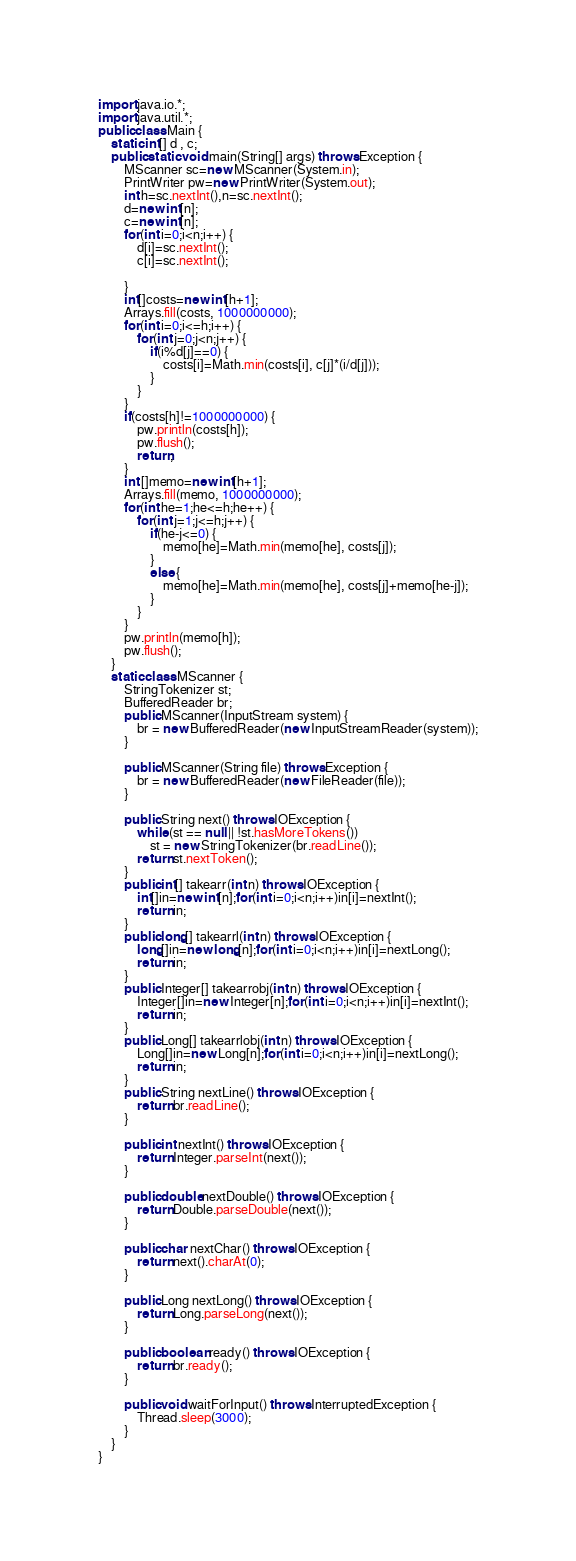Convert code to text. <code><loc_0><loc_0><loc_500><loc_500><_Java_>import java.io.*;
import java.util.*;
public class Main {
	static int[] d , c;
	public static void main(String[] args) throws Exception {
		MScanner sc=new MScanner(System.in);
		PrintWriter pw=new PrintWriter(System.out);
		int h=sc.nextInt(),n=sc.nextInt();
		d=new int[n];
		c=new int[n];
		for(int i=0;i<n;i++) {
			d[i]=sc.nextInt();
			c[i]=sc.nextInt();
			
		}
		int[]costs=new int[h+1];
		Arrays.fill(costs, 1000000000);
		for(int i=0;i<=h;i++) {
			for(int j=0;j<n;j++) {
				if(i%d[j]==0) {
					costs[i]=Math.min(costs[i], c[j]*(i/d[j]));
				}
			}
		}
		if(costs[h]!=1000000000) {
			pw.println(costs[h]);
			pw.flush();
			return;
		}
		int []memo=new int[h+1];
		Arrays.fill(memo, 1000000000);
		for(int he=1;he<=h;he++) {
			for(int j=1;j<=h;j++) {
				if(he-j<=0) {
					memo[he]=Math.min(memo[he], costs[j]);
				}
				else {
					memo[he]=Math.min(memo[he], costs[j]+memo[he-j]);
				}
			}
		}
		pw.println(memo[h]);
		pw.flush();
	}
	static class MScanner {
		StringTokenizer st;
		BufferedReader br;
		public MScanner(InputStream system) {
			br = new BufferedReader(new InputStreamReader(system));
		}
 
		public MScanner(String file) throws Exception {
			br = new BufferedReader(new FileReader(file));
		}
 
		public String next() throws IOException {
			while (st == null || !st.hasMoreTokens())
				st = new StringTokenizer(br.readLine());
			return st.nextToken();
		}
		public int[] takearr(int n) throws IOException {
	        int[]in=new int[n];for(int i=0;i<n;i++)in[i]=nextInt();
	        return in;
		}
		public long[] takearrl(int n) throws IOException {
	        long[]in=new long[n];for(int i=0;i<n;i++)in[i]=nextLong();
	        return in;
		}
		public Integer[] takearrobj(int n) throws IOException {
	        Integer[]in=new Integer[n];for(int i=0;i<n;i++)in[i]=nextInt();
	        return in;
		}
		public Long[] takearrlobj(int n) throws IOException {
	        Long[]in=new Long[n];for(int i=0;i<n;i++)in[i]=nextLong();
	        return in;
		}
		public String nextLine() throws IOException {
			return br.readLine();
		}
 
		public int nextInt() throws IOException {
			return Integer.parseInt(next());
		}
 
		public double nextDouble() throws IOException {
			return Double.parseDouble(next());
		}
 
		public char nextChar() throws IOException {
			return next().charAt(0);
		}
 
		public Long nextLong() throws IOException {
			return Long.parseLong(next());
		}
 
		public boolean ready() throws IOException {
			return br.ready();
		}
 
		public void waitForInput() throws InterruptedException {
			Thread.sleep(3000);
		}
	}
}
</code> 